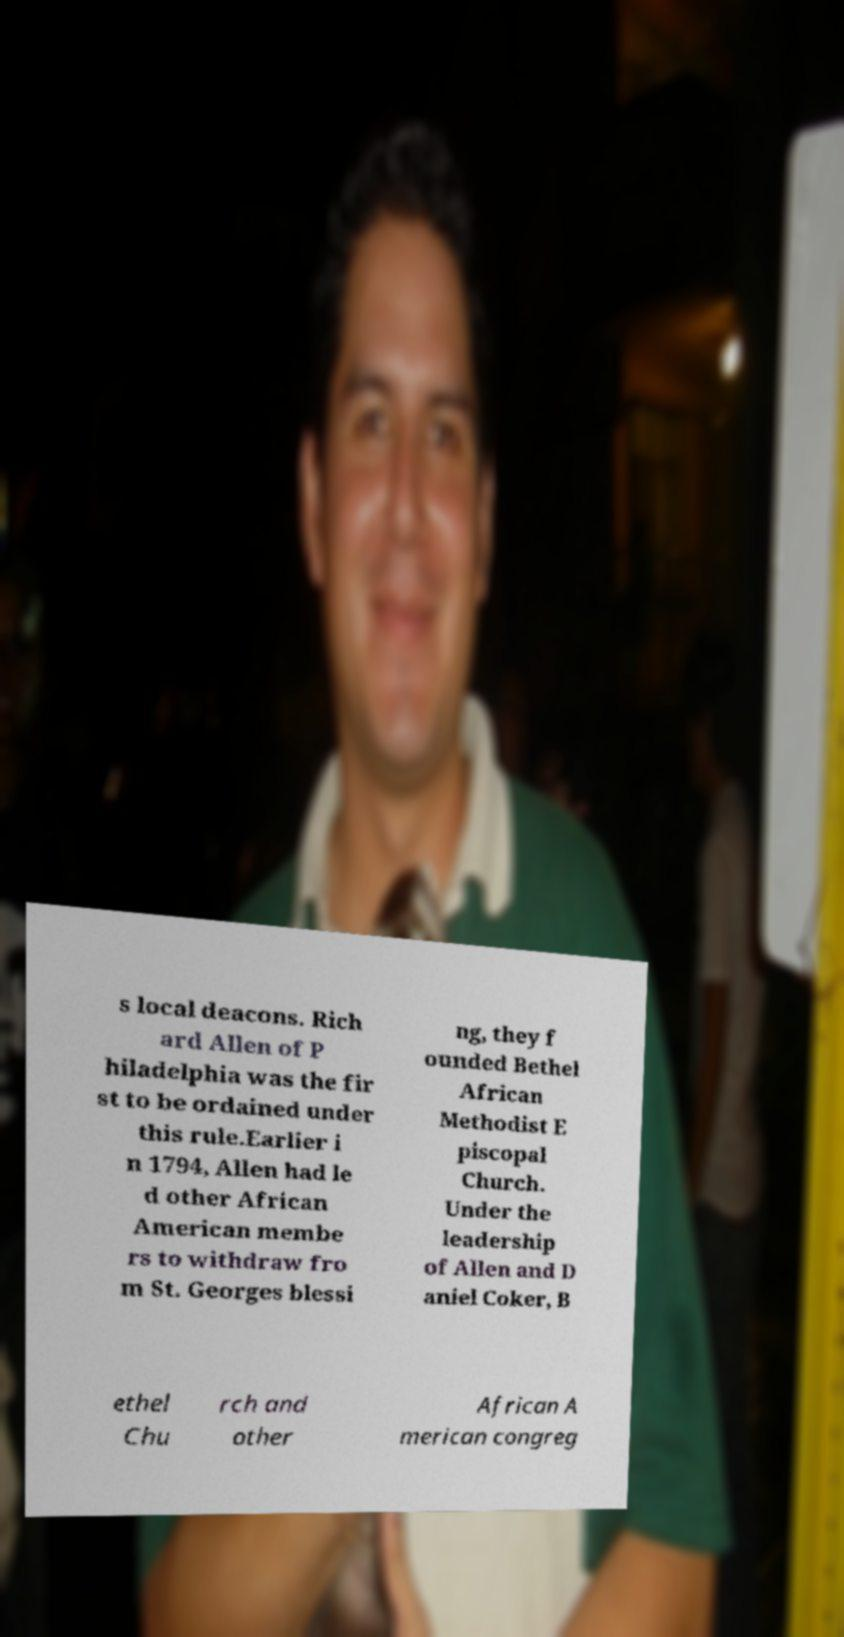Can you read and provide the text displayed in the image?This photo seems to have some interesting text. Can you extract and type it out for me? s local deacons. Rich ard Allen of P hiladelphia was the fir st to be ordained under this rule.Earlier i n 1794, Allen had le d other African American membe rs to withdraw fro m St. Georges blessi ng, they f ounded Bethel African Methodist E piscopal Church. Under the leadership of Allen and D aniel Coker, B ethel Chu rch and other African A merican congreg 